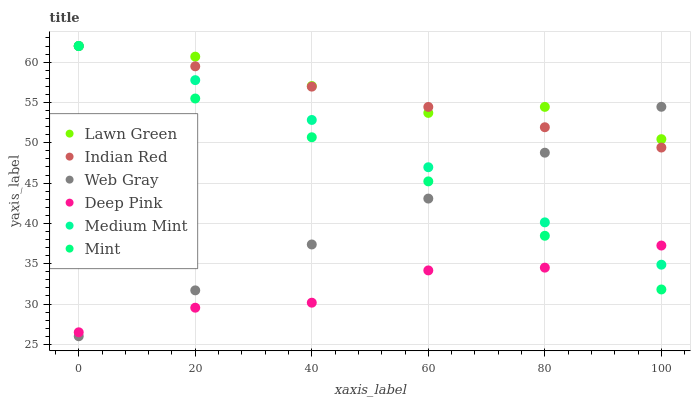Does Deep Pink have the minimum area under the curve?
Answer yes or no. Yes. Does Lawn Green have the maximum area under the curve?
Answer yes or no. Yes. Does Web Gray have the minimum area under the curve?
Answer yes or no. No. Does Web Gray have the maximum area under the curve?
Answer yes or no. No. Is Indian Red the smoothest?
Answer yes or no. Yes. Is Deep Pink the roughest?
Answer yes or no. Yes. Is Lawn Green the smoothest?
Answer yes or no. No. Is Lawn Green the roughest?
Answer yes or no. No. Does Web Gray have the lowest value?
Answer yes or no. Yes. Does Lawn Green have the lowest value?
Answer yes or no. No. Does Mint have the highest value?
Answer yes or no. Yes. Does Web Gray have the highest value?
Answer yes or no. No. Is Deep Pink less than Lawn Green?
Answer yes or no. Yes. Is Lawn Green greater than Deep Pink?
Answer yes or no. Yes. Does Mint intersect Web Gray?
Answer yes or no. Yes. Is Mint less than Web Gray?
Answer yes or no. No. Is Mint greater than Web Gray?
Answer yes or no. No. Does Deep Pink intersect Lawn Green?
Answer yes or no. No. 